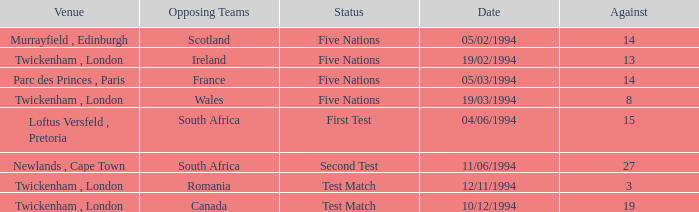Which venue has more than 19 against? Newlands , Cape Town. 